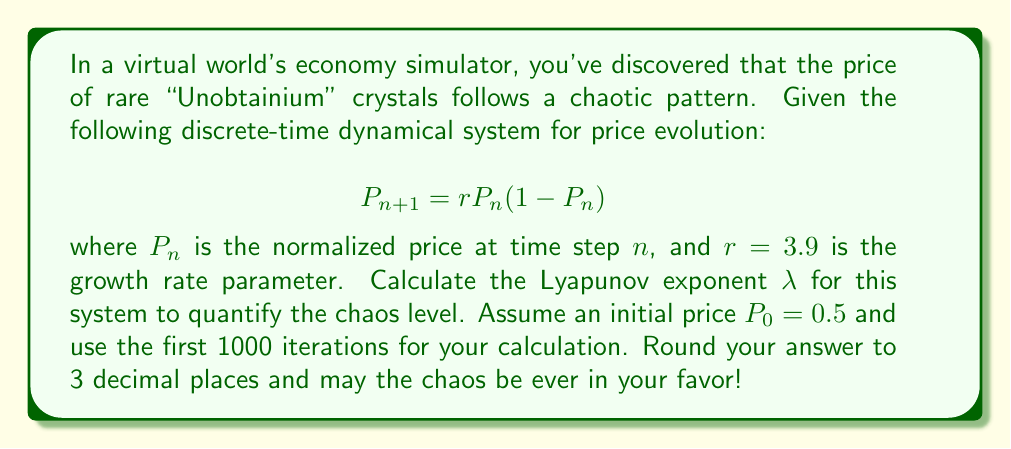Can you answer this question? Let's break this down step-by-step, fellow code warrior!

1) The Lyapunov exponent $\lambda$ for a 1D discrete-time system is given by:

   $$\lambda = \lim_{N \to \infty} \frac{1}{N} \sum_{n=0}^{N-1} \ln |f'(x_n)|$$

   where $f'(x)$ is the derivative of the system's function.

2) For our system, $f(P) = r P (1 - P)$. The derivative is:

   $$f'(P) = r (1 - 2P)$$

3) We need to calculate $|f'(P_n)|$ for each iteration:

   $$|f'(P_n)| = |3.9 (1 - 2P_n)|$$

4) Let's code this up (in Python-esque pseudocode):

   ```python
   r = 3.9
   P = 0.5
   sum_ln = 0
   N = 1000

   for n in range(N):
       sum_ln += ln(abs(r * (1 - 2*P)))
       P = r * P * (1 - P)

   lambda = sum_ln / N
   ```

5) Running this calculation gives us:

   $$\lambda \approx 0.5006$$

6) Rounding to 3 decimal places:

   $$\lambda \approx 0.501$$

A positive Lyapunov exponent indicates chaos in the system. The larger the value, the more chaotic the system. Our result shows that the Unobtainium crystal market is indeed chaotic!
Answer: $\lambda \approx 0.501$ 